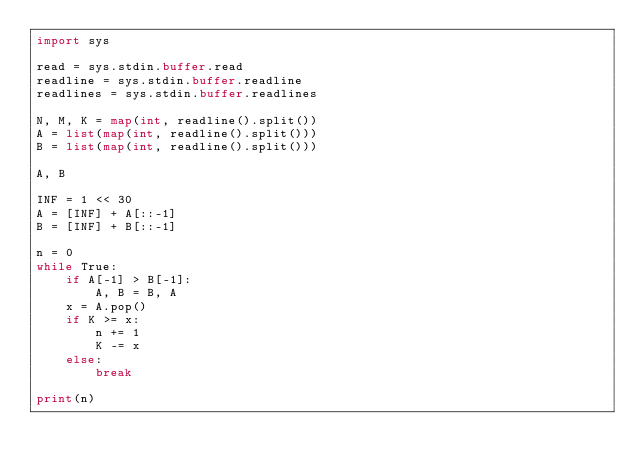<code> <loc_0><loc_0><loc_500><loc_500><_Python_>import sys

read = sys.stdin.buffer.read
readline = sys.stdin.buffer.readline
readlines = sys.stdin.buffer.readlines

N, M, K = map(int, readline().split())
A = list(map(int, readline().split()))
B = list(map(int, readline().split()))

A, B

INF = 1 << 30
A = [INF] + A[::-1]
B = [INF] + B[::-1]

n = 0
while True:
    if A[-1] > B[-1]:
        A, B = B, A
    x = A.pop()
    if K >= x:
        n += 1
        K -= x
    else:
        break

print(n)</code> 